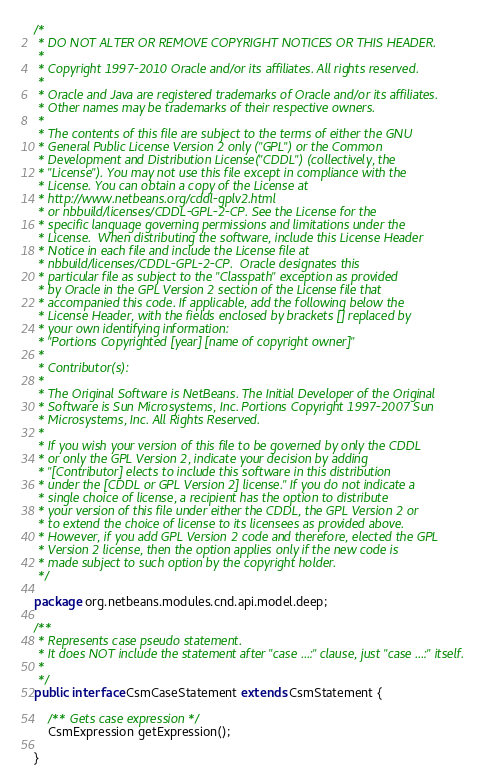<code> <loc_0><loc_0><loc_500><loc_500><_Java_>/*
 * DO NOT ALTER OR REMOVE COPYRIGHT NOTICES OR THIS HEADER.
 *
 * Copyright 1997-2010 Oracle and/or its affiliates. All rights reserved.
 *
 * Oracle and Java are registered trademarks of Oracle and/or its affiliates.
 * Other names may be trademarks of their respective owners.
 *
 * The contents of this file are subject to the terms of either the GNU
 * General Public License Version 2 only ("GPL") or the Common
 * Development and Distribution License("CDDL") (collectively, the
 * "License"). You may not use this file except in compliance with the
 * License. You can obtain a copy of the License at
 * http://www.netbeans.org/cddl-gplv2.html
 * or nbbuild/licenses/CDDL-GPL-2-CP. See the License for the
 * specific language governing permissions and limitations under the
 * License.  When distributing the software, include this License Header
 * Notice in each file and include the License file at
 * nbbuild/licenses/CDDL-GPL-2-CP.  Oracle designates this
 * particular file as subject to the "Classpath" exception as provided
 * by Oracle in the GPL Version 2 section of the License file that
 * accompanied this code. If applicable, add the following below the
 * License Header, with the fields enclosed by brackets [] replaced by
 * your own identifying information:
 * "Portions Copyrighted [year] [name of copyright owner]"
 *
 * Contributor(s):
 *
 * The Original Software is NetBeans. The Initial Developer of the Original
 * Software is Sun Microsystems, Inc. Portions Copyright 1997-2007 Sun
 * Microsystems, Inc. All Rights Reserved.
 *
 * If you wish your version of this file to be governed by only the CDDL
 * or only the GPL Version 2, indicate your decision by adding
 * "[Contributor] elects to include this software in this distribution
 * under the [CDDL or GPL Version 2] license." If you do not indicate a
 * single choice of license, a recipient has the option to distribute
 * your version of this file under either the CDDL, the GPL Version 2 or
 * to extend the choice of license to its licensees as provided above.
 * However, if you add GPL Version 2 code and therefore, elected the GPL
 * Version 2 license, then the option applies only if the new code is
 * made subject to such option by the copyright holder.
 */

package org.netbeans.modules.cnd.api.model.deep;

/**
 * Represents case pseudo statement.
 * It does NOT include the statement after "case ...:" clause, just "case ...:" itself.
 *
 */
public interface CsmCaseStatement extends CsmStatement {

    /** Gets case expression */
    CsmExpression getExpression();

}
</code> 